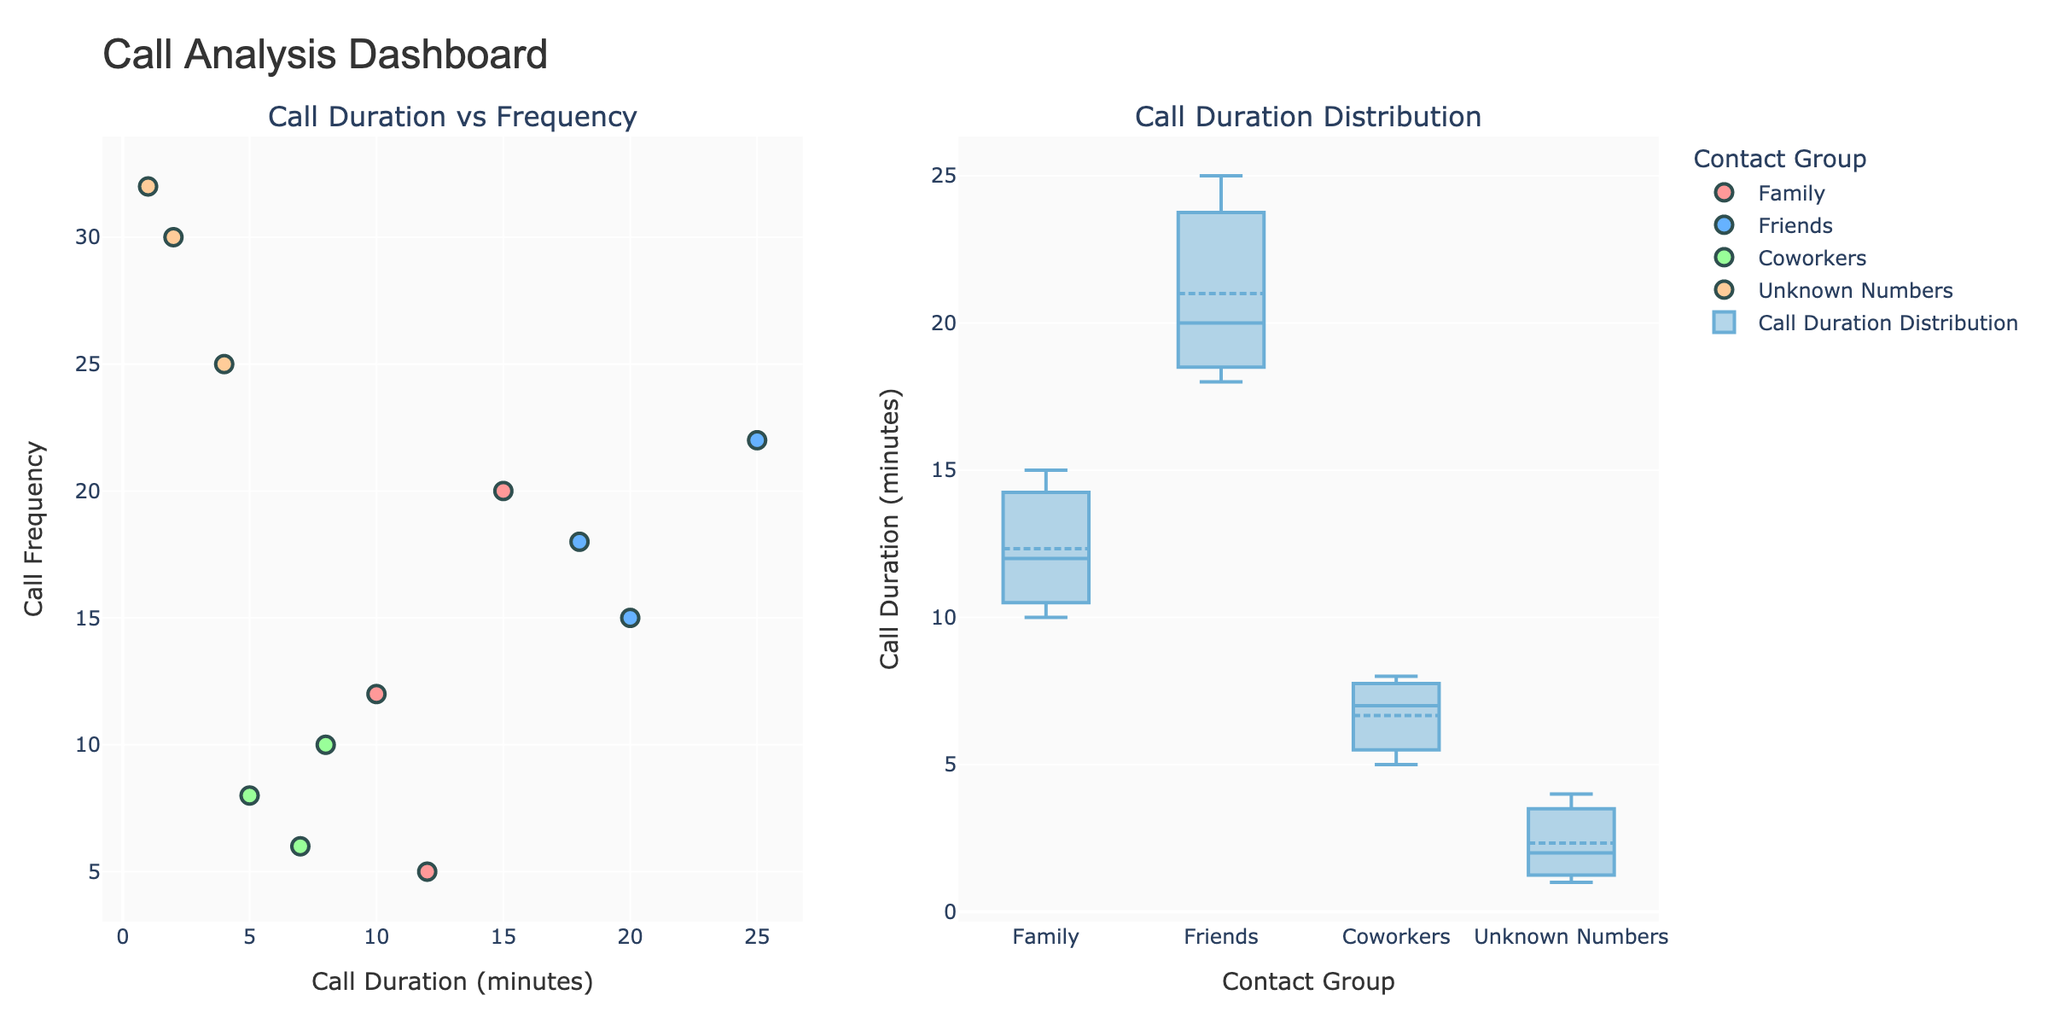what is the color used for the 'Friends' group? Looking at the scatter plot, each contact group has a different color. The 'Friends' group is represented by the blue-colored markers.
Answer: Blue which contact group has the highest call frequency rate? Reviewing the scatter plot, the 'Unknown Numbers' group shows the highest call frequency with some points around 30-32 calls.
Answer: Unknown Numbers what is the median call duration for the 'Coworkers' group? From the box plot, the median is indicated by the line inside the box. The 'Coworkers' group's median call duration appears to be around 7 minutes.
Answer: 7 minutes are there more calls made by 'Family' or 'Friends' contacts? By counting the markers in the scatter plot, the 'Family' group has 3 markers, while the 'Friends' group also has 3 markers. Both have the same number of calls in the dataset.
Answer: Both are equal which contact group has the smallest range in call duration? Evaluating the box plot, the smallest range in call duration appears to be around the 'Coworkers', as the box and whiskers are short.
Answer: Coworkers what is the average call duration for the 'Family' group? 'Family' group call durations are 10, 15, and 12. Adding these values gives 37. Dividing by the 3 contacts, the average call duration is 37/3 = 12.33 minutes.
Answer: 12.33 minutes how many data points exist for the 'Unknown Numbers'? By counting the markers in the scatter plot, there are 3 data points for the 'Unknown Numbers' group.
Answer: 3 which contact group has the widest variation in call duration? From the box plot, the largest spread appears in the 'Friends' group, indicating the widest variation in call duration.
Answer: Friends are call durations for 'Coworkers' generally longer or shorter compared to 'Friends'? According to the scatter plot, the 'Friends' group has longer call durations (18-25 minutes) than the 'Coworkers' group (5-8 minutes).
Answer: Shorter in the scatter plot, what information is displayed when hovering over a marker? Hovering over a marker displays the contact name, call duration, and call frequency for that data point.
Answer: Contact name, call duration, call frequency 